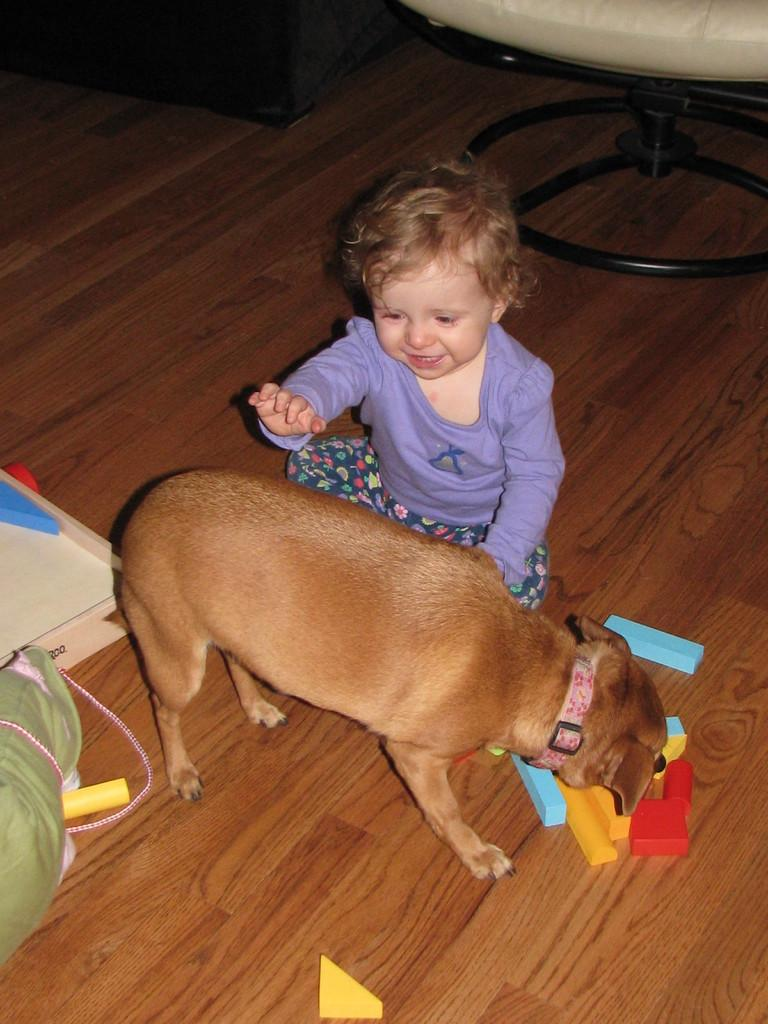What is the kid doing in the image? The kid is sitting on the wooden floor in the image. What type of animal is present in the image? There is a dog in the image. What else can be seen in the image besides the kid and the dog? There are toys in the image. Can you describe any furniture in the image? There appears to be a chair in the top right corner of the image. What other unspecified objects are present in the image? There are other unspecified objects in the image, but we cannot determine their exact nature from the provided facts. What type of company is the kid working for in the image? There is no indication in the image that the kid is working for any company, as the image shows a kid sitting on the wooden floor with a dog and toys. 